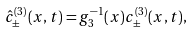Convert formula to latex. <formula><loc_0><loc_0><loc_500><loc_500>\hat { c } _ { \pm } ^ { ( 3 ) } ( x , t ) = g _ { 3 } ^ { - 1 } ( x ) c _ { \pm } ^ { ( 3 ) } ( x , t ) ,</formula> 